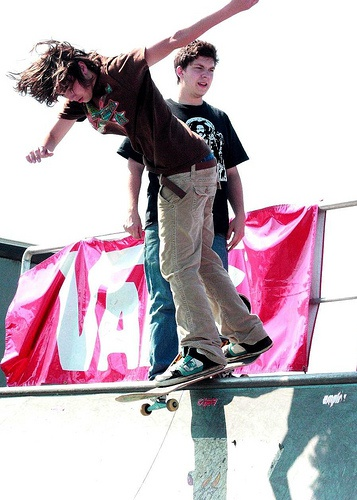Describe the objects in this image and their specific colors. I can see people in white, black, gray, and darkgray tones, people in white, black, gray, and blue tones, and skateboard in white, darkgray, gray, and black tones in this image. 